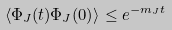<formula> <loc_0><loc_0><loc_500><loc_500>\langle \Phi _ { J } ( t ) \Phi _ { J } ( 0 ) \rangle \leq e ^ { - m _ { J } t }</formula> 